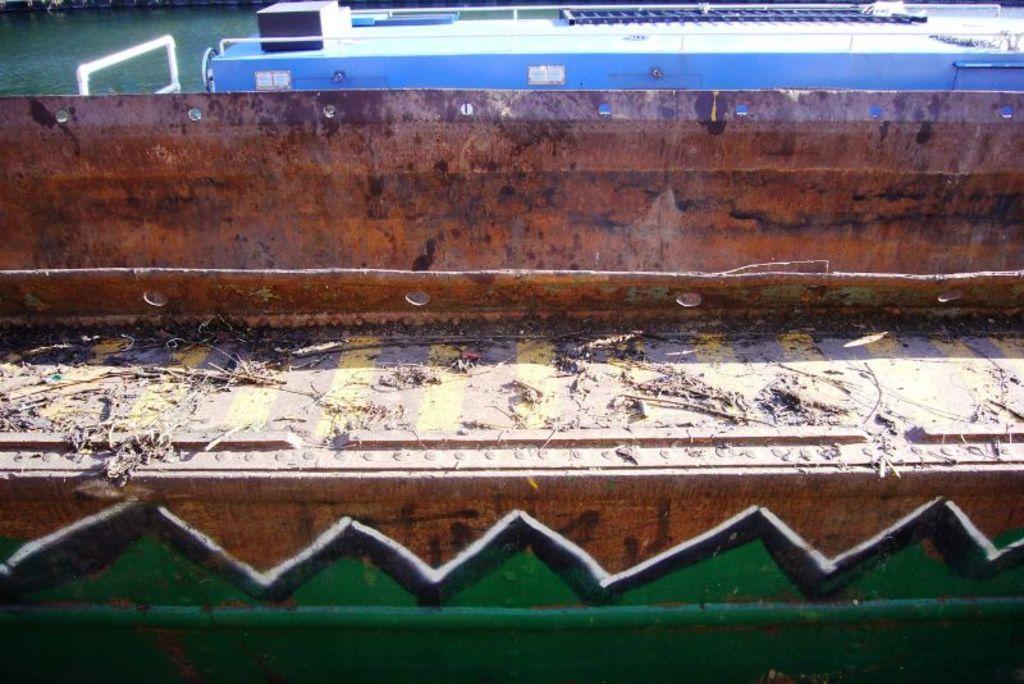Describe this image in one or two sentences. This image is taken outdoors. At the top of the image there is a pond with water and there is a boat in the pond. In the middle of the image there is a metal object. There is dirt on the metal object. 